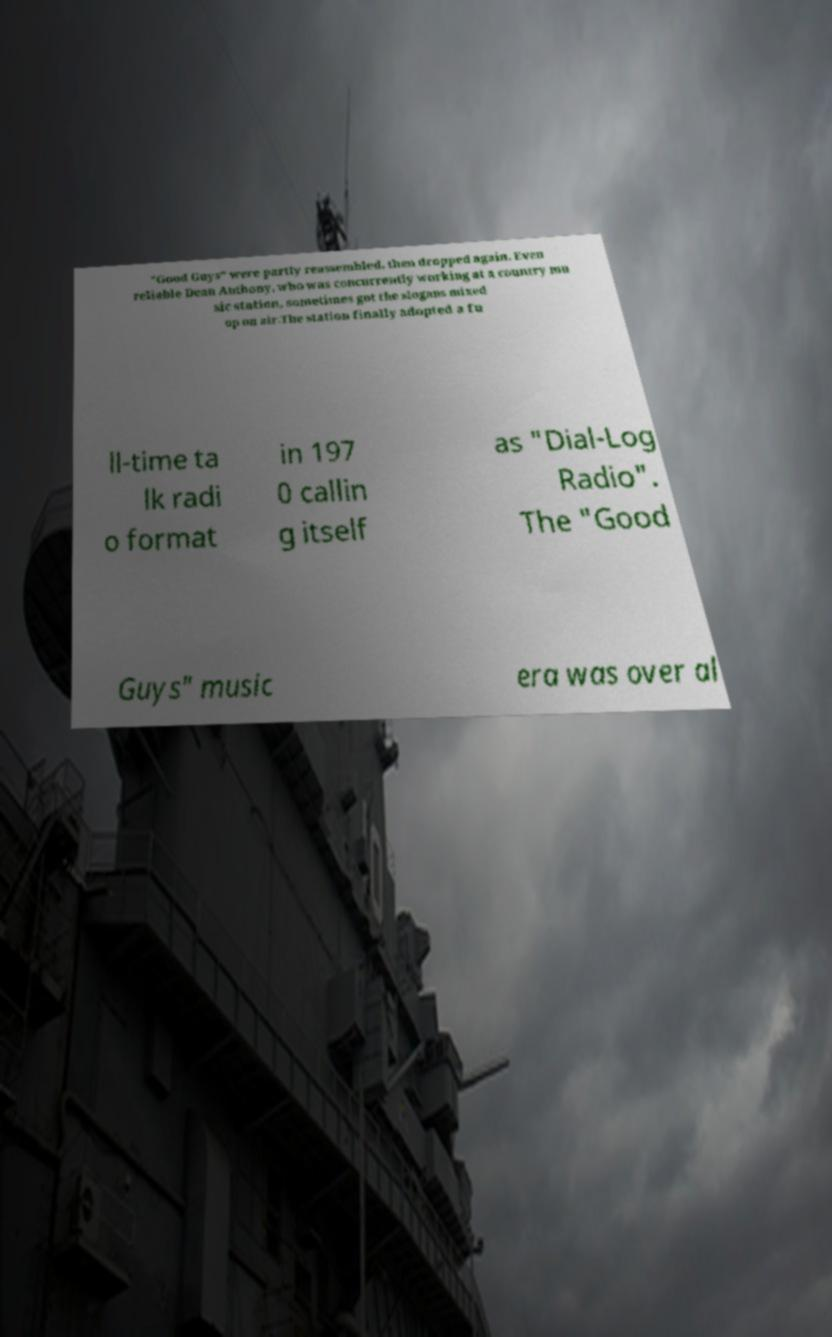Can you accurately transcribe the text from the provided image for me? "Good Guys" were partly reassembled, then dropped again. Even reliable Dean Anthony, who was concurrently working at a country mu sic station, sometimes got the slogans mixed up on air.The station finally adopted a fu ll-time ta lk radi o format in 197 0 callin g itself as "Dial-Log Radio". The "Good Guys" music era was over al 